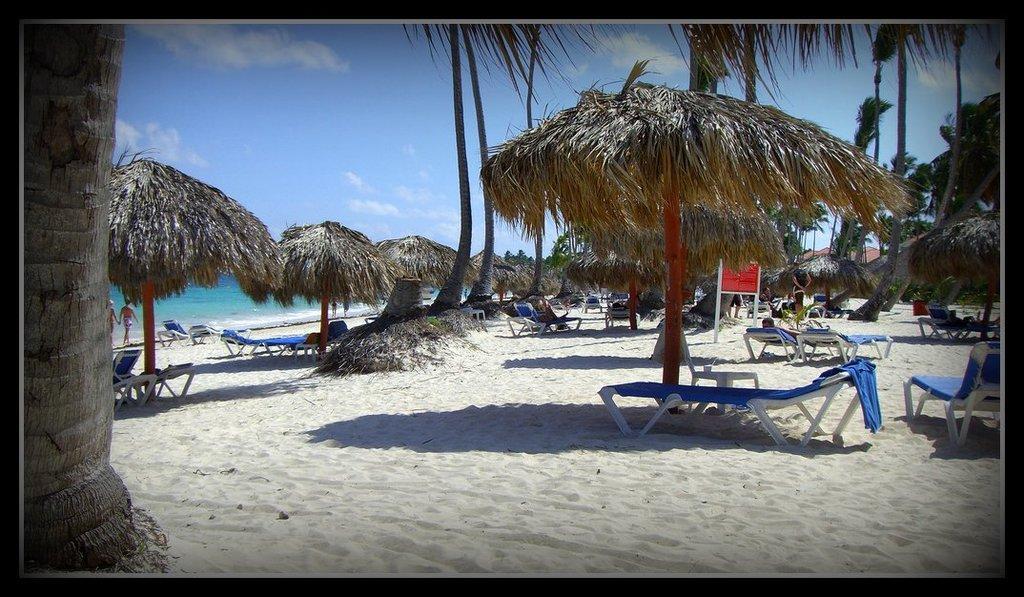In one or two sentences, can you explain what this image depicts? In this image we can see a picture of a beach. In this picture there are single pole huts, chairs, people, a board, sand, trees, water, a red board, blue clothes and a cloudy sky. 